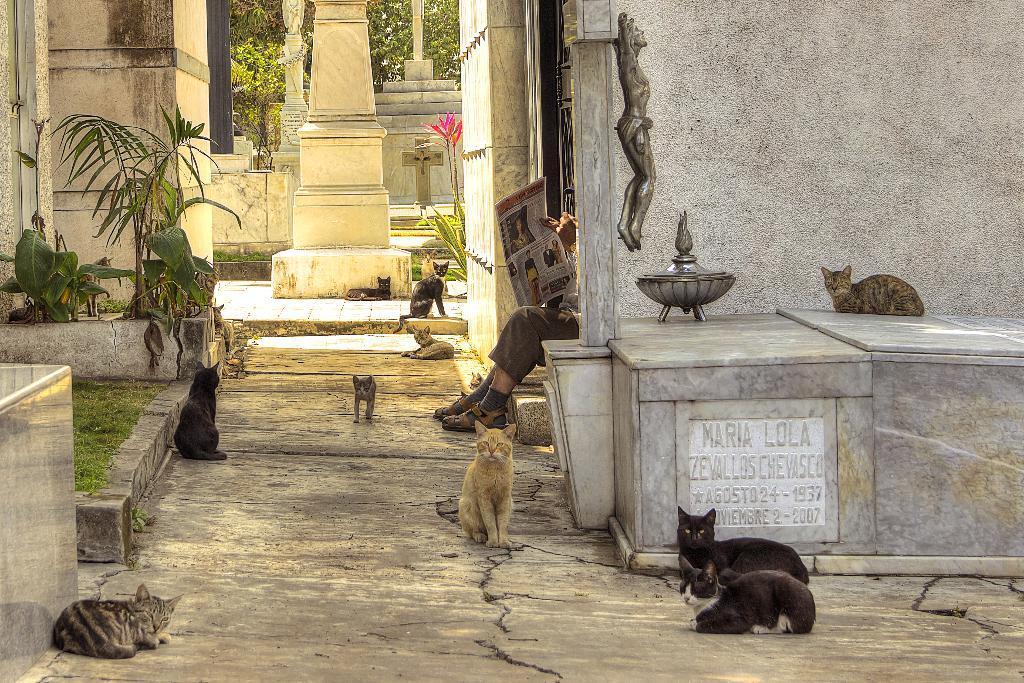In one or two sentences, can you explain what this image depicts? In this picture we can see some cats, on the right side there is a house, we can see a person is sitting and holding a paper in the middle, on the left side we can see grass and plants, in the background we can see a pillar and trees. 